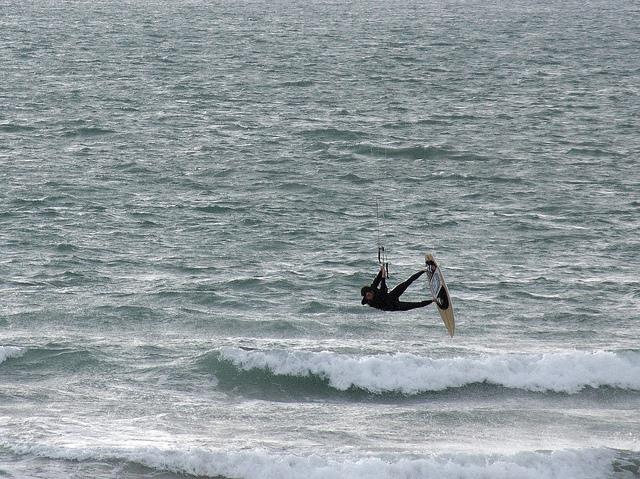What would you call this body of water?
Give a very brief answer. Ocean. What are the men holding?
Write a very short answer. Rope. What color wetsuit is the man wearing?
Give a very brief answer. Black. What does the person have on their feet?
Give a very brief answer. Surfboard. 